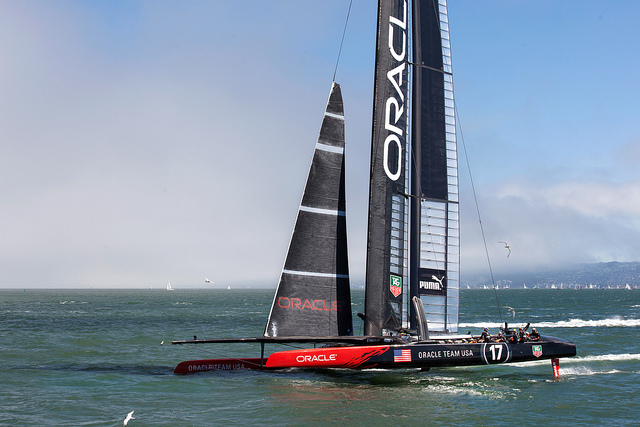<image>What is the advertising asking the reader to do? It is ambiguous what the advertising is asking the reader to do. It may not contain any advertising. What is the advertising asking the reader to do? The advertising is asking the reader to use Oracle's cloud services. 